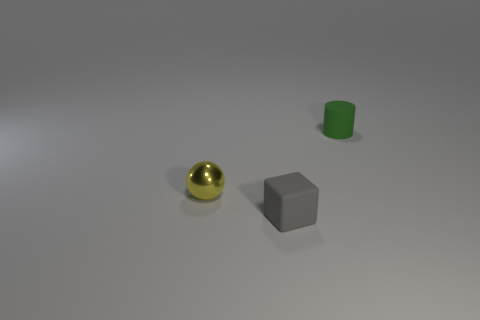Add 2 spheres. How many objects exist? 5 Subtract all balls. How many objects are left? 2 Add 3 big brown things. How many big brown things exist? 3 Subtract 0 purple cylinders. How many objects are left? 3 Subtract all matte blocks. Subtract all yellow shiny spheres. How many objects are left? 1 Add 2 matte objects. How many matte objects are left? 4 